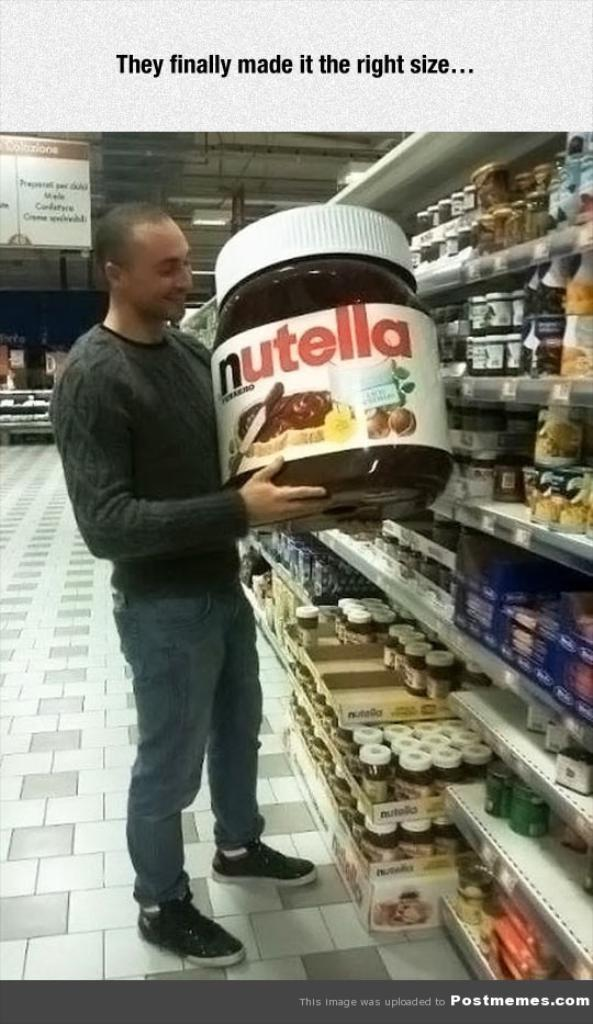<image>
Create a compact narrative representing the image presented. A man in a store is holding a giant bottle of Nutella. 